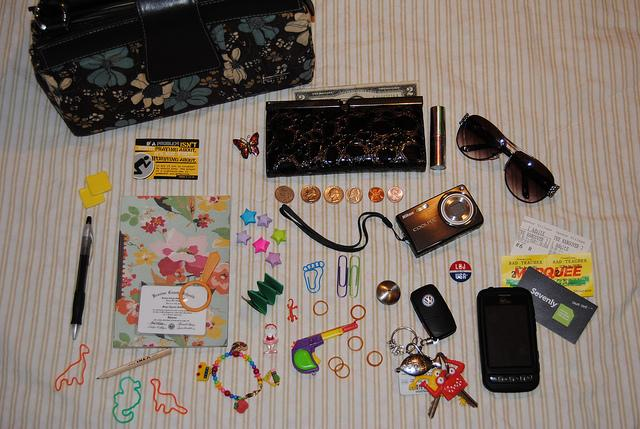What brand of car does this person drive? volkswagen 